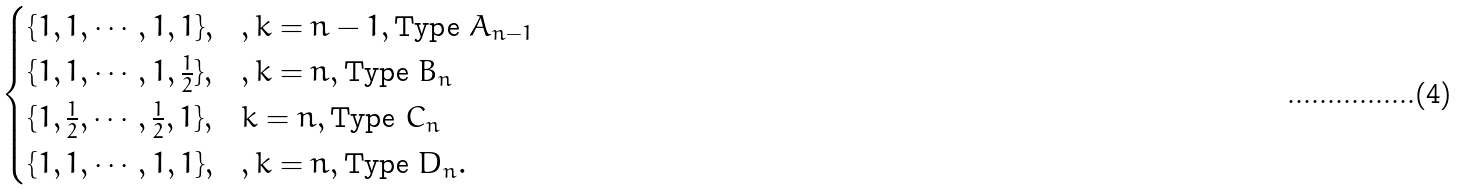<formula> <loc_0><loc_0><loc_500><loc_500>\begin{cases} \{ 1 , 1 , \cdots , 1 , 1 \} , & , k = n - 1 , \text {Type $A_{n-1}$} \\ \{ 1 , 1 , \cdots , 1 , \frac { 1 } { 2 } \} , & , k = n , \text {Type $B_{n}$} \\ \{ 1 , \frac { 1 } { 2 } , \cdots , \frac { 1 } { 2 } , 1 \} , & k = n , \text {Type $C_{n}$} \\ \{ 1 , 1 , \cdots , 1 , 1 \} , & , k = n , \text {Type $D_{n}$} . \end{cases}</formula> 